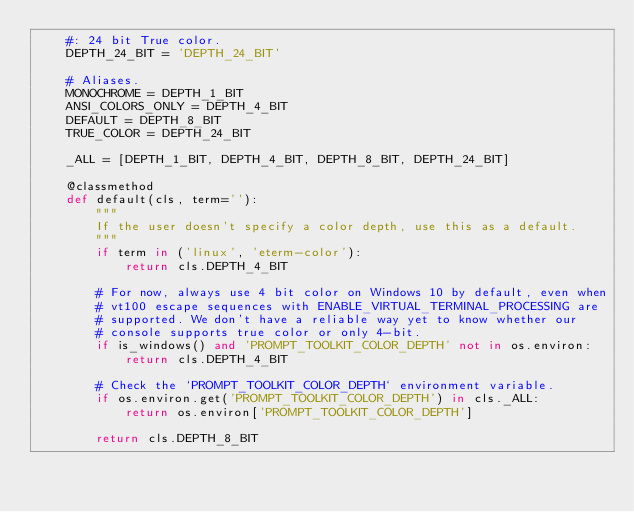<code> <loc_0><loc_0><loc_500><loc_500><_Python_>    #: 24 bit True color.
    DEPTH_24_BIT = 'DEPTH_24_BIT'

    # Aliases.
    MONOCHROME = DEPTH_1_BIT
    ANSI_COLORS_ONLY = DEPTH_4_BIT
    DEFAULT = DEPTH_8_BIT
    TRUE_COLOR = DEPTH_24_BIT

    _ALL = [DEPTH_1_BIT, DEPTH_4_BIT, DEPTH_8_BIT, DEPTH_24_BIT]

    @classmethod
    def default(cls, term=''):
        """
        If the user doesn't specify a color depth, use this as a default.
        """
        if term in ('linux', 'eterm-color'):
            return cls.DEPTH_4_BIT

        # For now, always use 4 bit color on Windows 10 by default, even when
        # vt100 escape sequences with ENABLE_VIRTUAL_TERMINAL_PROCESSING are
        # supported. We don't have a reliable way yet to know whether our
        # console supports true color or only 4-bit.
        if is_windows() and 'PROMPT_TOOLKIT_COLOR_DEPTH' not in os.environ:
            return cls.DEPTH_4_BIT

        # Check the `PROMPT_TOOLKIT_COLOR_DEPTH` environment variable.
        if os.environ.get('PROMPT_TOOLKIT_COLOR_DEPTH') in cls._ALL:
            return os.environ['PROMPT_TOOLKIT_COLOR_DEPTH']

        return cls.DEPTH_8_BIT
</code> 